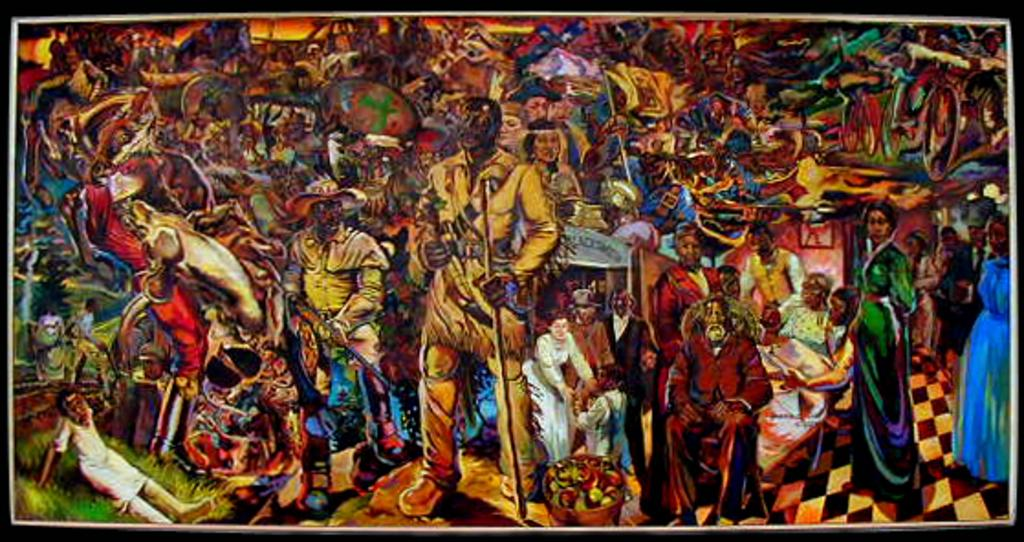What is the main subject of the image? The main subject of the image is a painting. What can be seen in the painting? The painting contains different kinds of persons. Is there a river or any body of water visible in the painting? There is no mention of a river or any body of water in the provided facts about the image. 